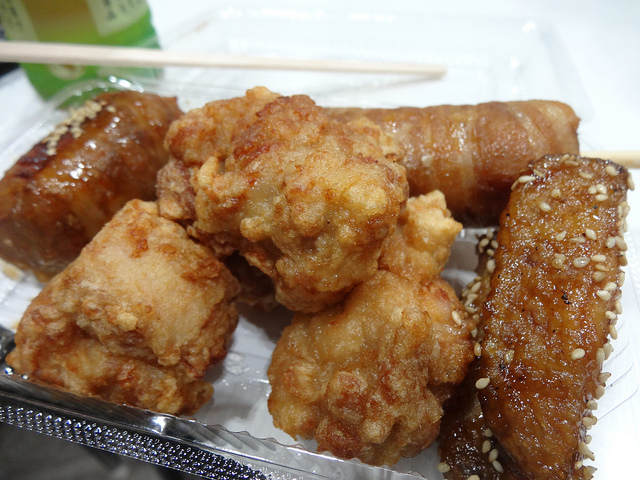<image>What is this food? I am uncertain about the food. It could be churros, fried wonton, apple fruit, chicken, or pastries. What is this food? I am not sure what this food is. It could be churros, fried wonton, apple fruit, chicken, or pastries. 